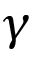Convert formula to latex. <formula><loc_0><loc_0><loc_500><loc_500>\gamma</formula> 